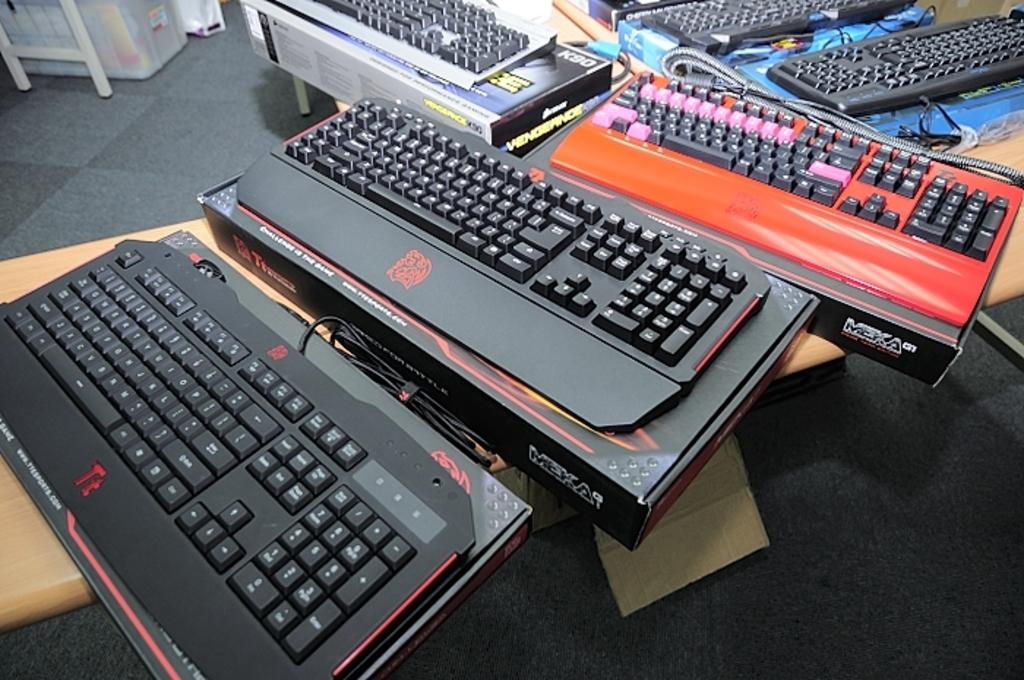<image>
Summarize the visual content of the image. Several Meka computer keyboards are on tables inside a building. 